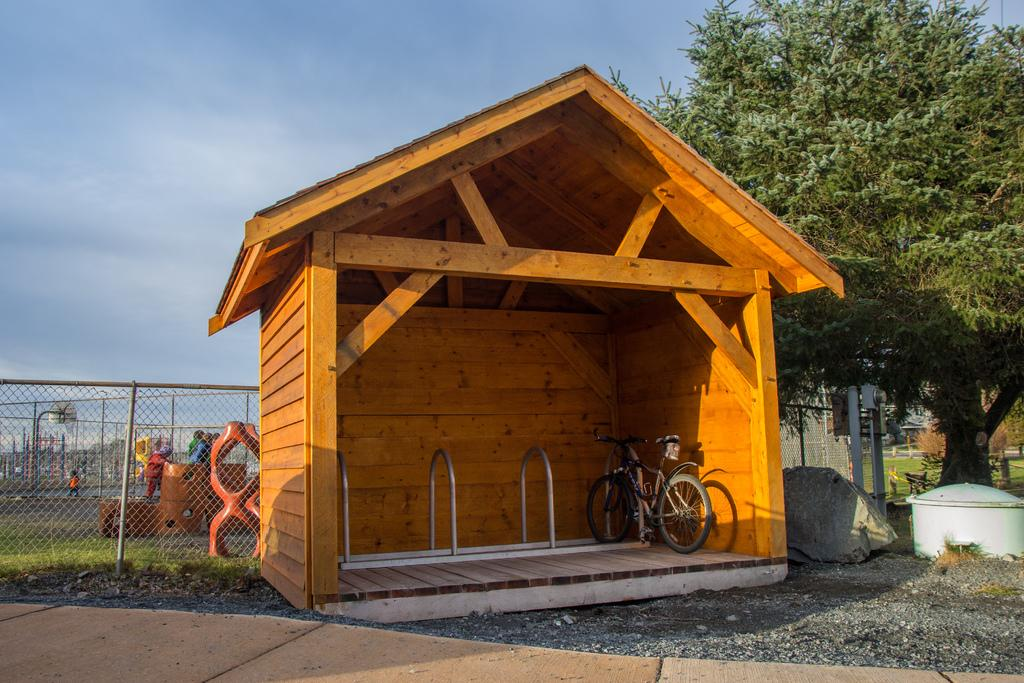What type of structure is present in the image? There is a wooden shed house in the image. What natural elements can be seen in the image? There are trees and grass in the image. What type of material is used for the mesh in the image? The mesh in the image is not described in terms of material, but it is visible. What mode of transportation is present in the image? There is a bicycle in the image. What architectural feature can be seen in the image? There is a pole in the image. What part of the natural environment is visible in the image? The sky is visible in the image. What type of property does the mind own in the image? There is no mention of a mind or property in the image; it features a wooden shed house, trees, grass, mesh, a bicycle, a pole, and the sky. 